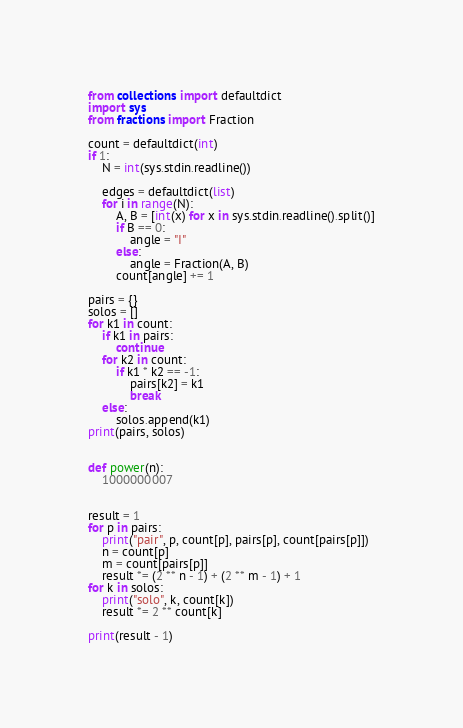Convert code to text. <code><loc_0><loc_0><loc_500><loc_500><_Python_>from collections import defaultdict
import sys
from fractions import Fraction

count = defaultdict(int)
if 1:
    N = int(sys.stdin.readline())

    edges = defaultdict(list)
    for i in range(N):
        A, B = [int(x) for x in sys.stdin.readline().split()]
        if B == 0:
            angle = "I"
        else:
            angle = Fraction(A, B)
        count[angle] += 1

pairs = {}
solos = []
for k1 in count:
    if k1 in pairs:
        continue
    for k2 in count:
        if k1 * k2 == -1:
            pairs[k2] = k1
            break
    else:
        solos.append(k1)
print(pairs, solos)


def power(n):
    1000000007


result = 1
for p in pairs:
    print("pair", p, count[p], pairs[p], count[pairs[p]])
    n = count[p]
    m = count[pairs[p]]
    result *= (2 ** n - 1) + (2 ** m - 1) + 1
for k in solos:
    print("solo", k, count[k])
    result *= 2 ** count[k]

print(result - 1)
</code> 